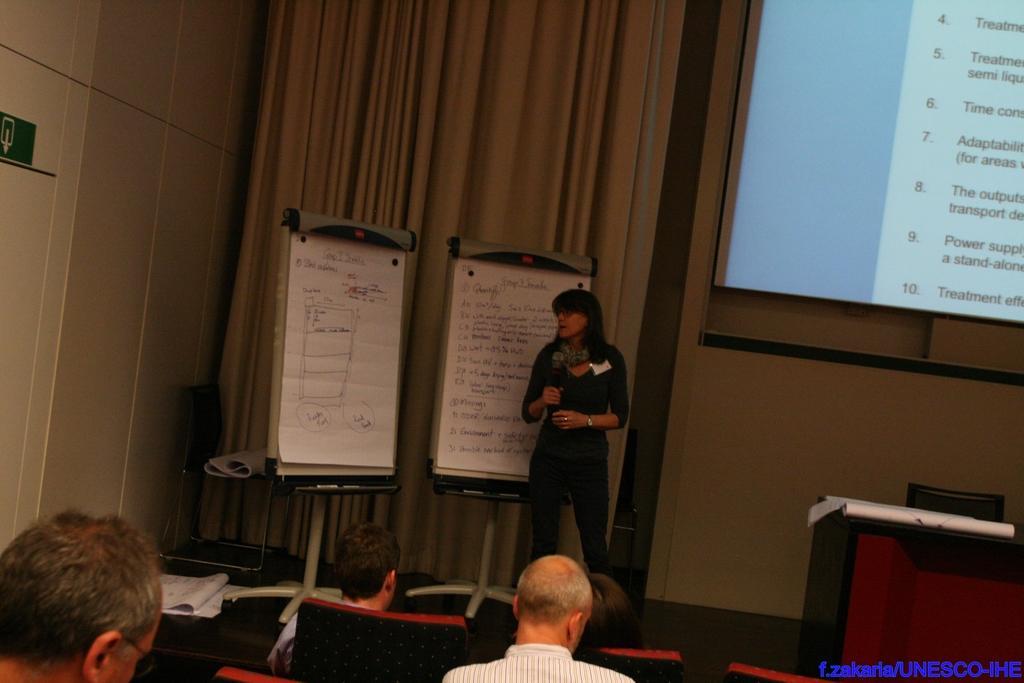How would you summarize this image in a sentence or two? In this image I can see at the bottom few people are sitting on the chairs. In the middle there are boats and a woman is standing and speaking into microphone. On the right side there is the projector screen. In the right hand side bottom there is the name in blue color and there is a table and a chair. 